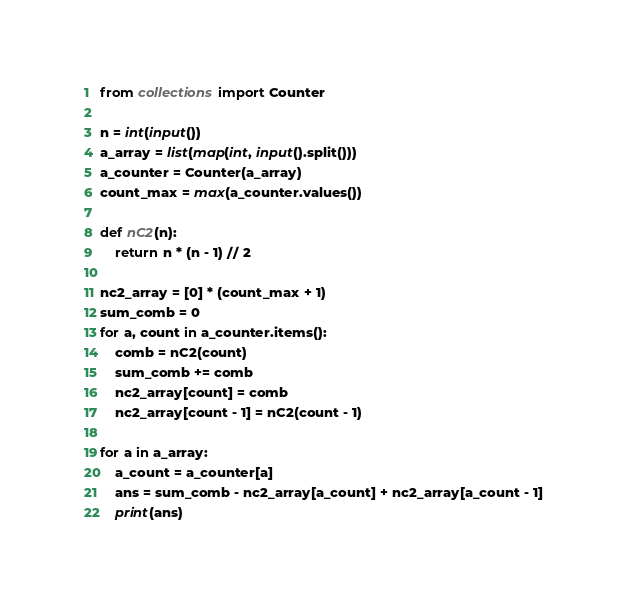<code> <loc_0><loc_0><loc_500><loc_500><_Python_>from collections import Counter

n = int(input())
a_array = list(map(int, input().split()))
a_counter = Counter(a_array)
count_max = max(a_counter.values())

def nC2(n):
    return n * (n - 1) // 2

nc2_array = [0] * (count_max + 1)
sum_comb = 0
for a, count in a_counter.items():
    comb = nC2(count)
    sum_comb += comb
    nc2_array[count] = comb
    nc2_array[count - 1] = nC2(count - 1)

for a in a_array:
    a_count = a_counter[a]
    ans = sum_comb - nc2_array[a_count] + nc2_array[a_count - 1]
    print(ans)</code> 